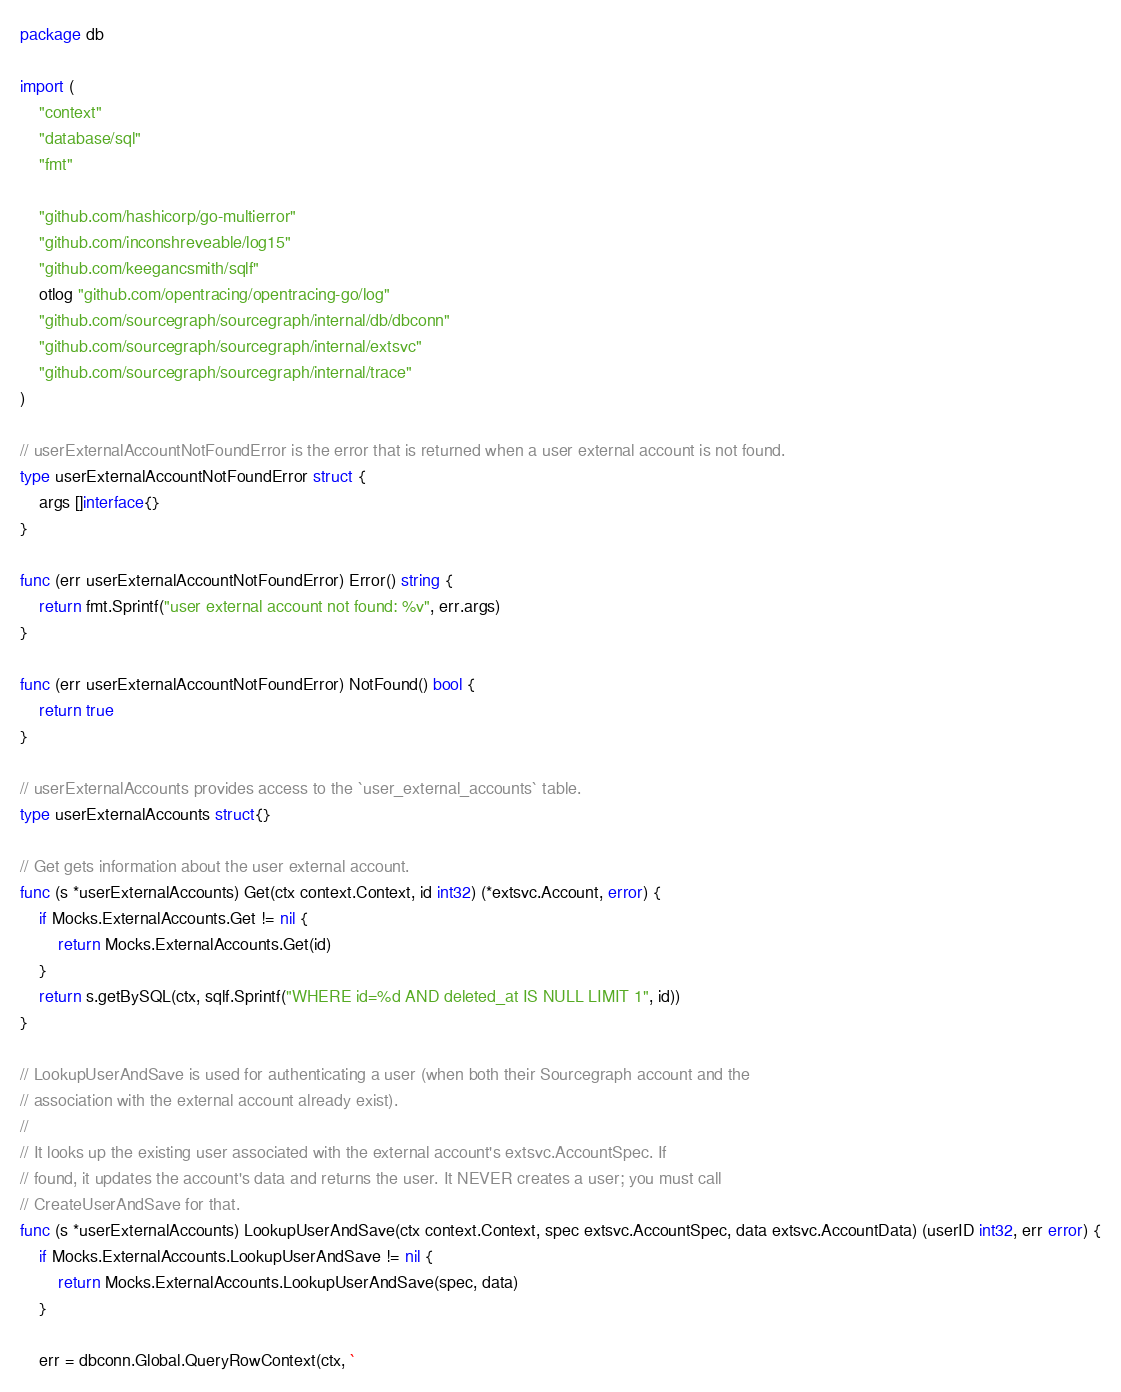Convert code to text. <code><loc_0><loc_0><loc_500><loc_500><_Go_>package db

import (
	"context"
	"database/sql"
	"fmt"

	"github.com/hashicorp/go-multierror"
	"github.com/inconshreveable/log15"
	"github.com/keegancsmith/sqlf"
	otlog "github.com/opentracing/opentracing-go/log"
	"github.com/sourcegraph/sourcegraph/internal/db/dbconn"
	"github.com/sourcegraph/sourcegraph/internal/extsvc"
	"github.com/sourcegraph/sourcegraph/internal/trace"
)

// userExternalAccountNotFoundError is the error that is returned when a user external account is not found.
type userExternalAccountNotFoundError struct {
	args []interface{}
}

func (err userExternalAccountNotFoundError) Error() string {
	return fmt.Sprintf("user external account not found: %v", err.args)
}

func (err userExternalAccountNotFoundError) NotFound() bool {
	return true
}

// userExternalAccounts provides access to the `user_external_accounts` table.
type userExternalAccounts struct{}

// Get gets information about the user external account.
func (s *userExternalAccounts) Get(ctx context.Context, id int32) (*extsvc.Account, error) {
	if Mocks.ExternalAccounts.Get != nil {
		return Mocks.ExternalAccounts.Get(id)
	}
	return s.getBySQL(ctx, sqlf.Sprintf("WHERE id=%d AND deleted_at IS NULL LIMIT 1", id))
}

// LookupUserAndSave is used for authenticating a user (when both their Sourcegraph account and the
// association with the external account already exist).
//
// It looks up the existing user associated with the external account's extsvc.AccountSpec. If
// found, it updates the account's data and returns the user. It NEVER creates a user; you must call
// CreateUserAndSave for that.
func (s *userExternalAccounts) LookupUserAndSave(ctx context.Context, spec extsvc.AccountSpec, data extsvc.AccountData) (userID int32, err error) {
	if Mocks.ExternalAccounts.LookupUserAndSave != nil {
		return Mocks.ExternalAccounts.LookupUserAndSave(spec, data)
	}

	err = dbconn.Global.QueryRowContext(ctx, `</code> 